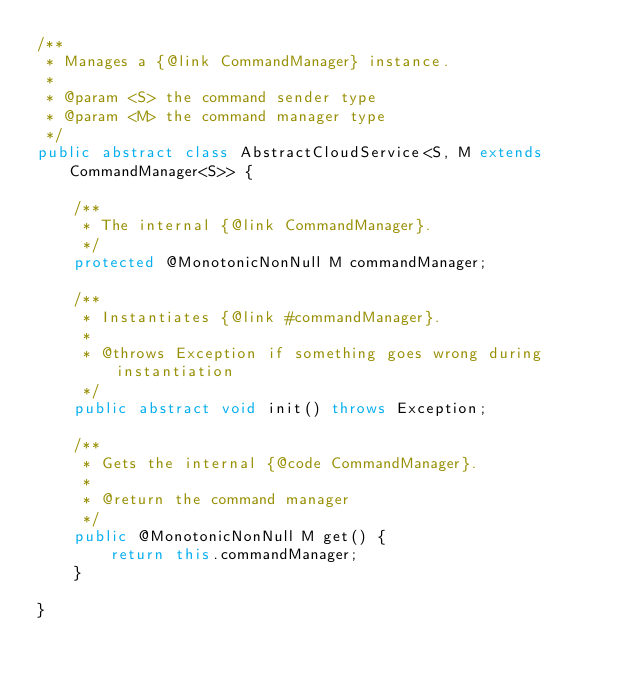Convert code to text. <code><loc_0><loc_0><loc_500><loc_500><_Java_>/**
 * Manages a {@link CommandManager} instance.
 *
 * @param <S> the command sender type
 * @param <M> the command manager type
 */
public abstract class AbstractCloudService<S, M extends CommandManager<S>> {

    /**
     * The internal {@link CommandManager}.
     */
    protected @MonotonicNonNull M commandManager;

    /**
     * Instantiates {@link #commandManager}.
     *
     * @throws Exception if something goes wrong during instantiation
     */
    public abstract void init() throws Exception;

    /**
     * Gets the internal {@code CommandManager}.
     *
     * @return the command manager
     */
    public @MonotonicNonNull M get() {
        return this.commandManager;
    }

}
</code> 